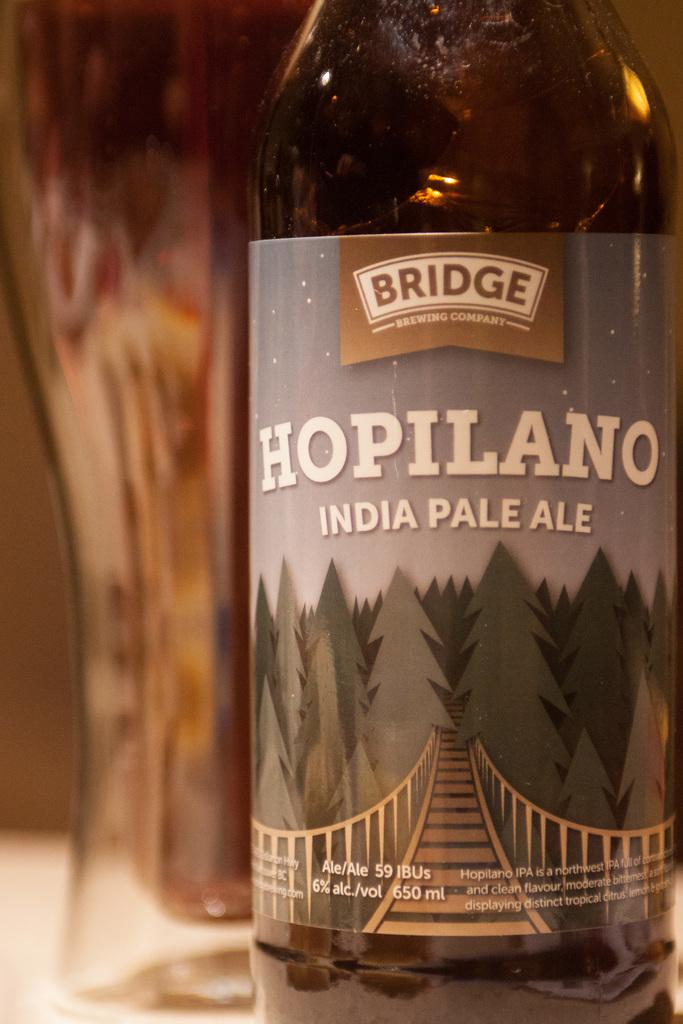<image>
Provide a brief description of the given image. the word bridge that is on a bottle 